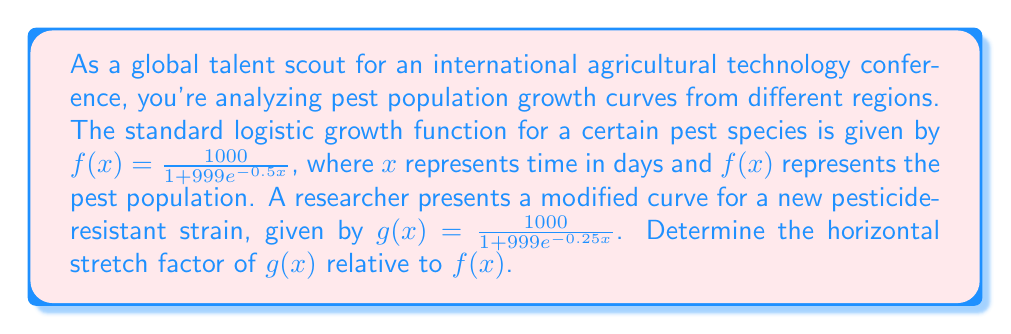Can you solve this math problem? To determine the horizontal stretch factor, we need to compare the equations of $f(x)$ and $g(x)$:

1. Standard function: $f(x) = \frac{1000}{1 + 999e^{-0.5x}}$
2. Modified function: $g(x) = \frac{1000}{1 + 999e^{-0.25x}}$

The general form of a horizontal stretch is:
$g(x) = f(\frac{x}{k})$, where $k$ is the stretch factor.

In this case, we need to find $k$ such that:

$\frac{1000}{1 + 999e^{-0.25x}} = \frac{1000}{1 + 999e^{-0.5(\frac{x}{k})}}$

For this equality to hold, the exponents must be equal:

$-0.25x = -0.5(\frac{x}{k})$

Simplifying:
$-0.25x = -\frac{0.5x}{k}$

$0.25k = 0.5$

$k = \frac{0.5}{0.25} = 2$

Therefore, the horizontal stretch factor is 2, meaning $g(x)$ is stretched horizontally by a factor of 2 compared to $f(x)$. This indicates that the pesticide-resistant strain grows at half the rate of the original strain, taking twice as long to reach the same population levels.
Answer: The horizontal stretch factor is 2. 